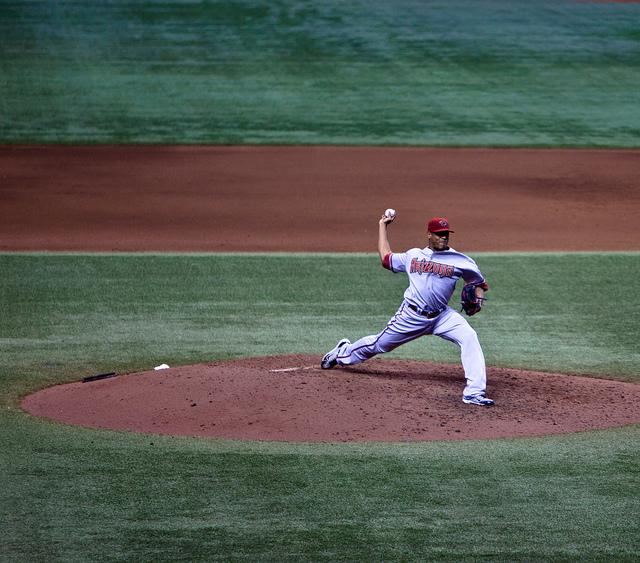What kind of throw is that called? pitch 